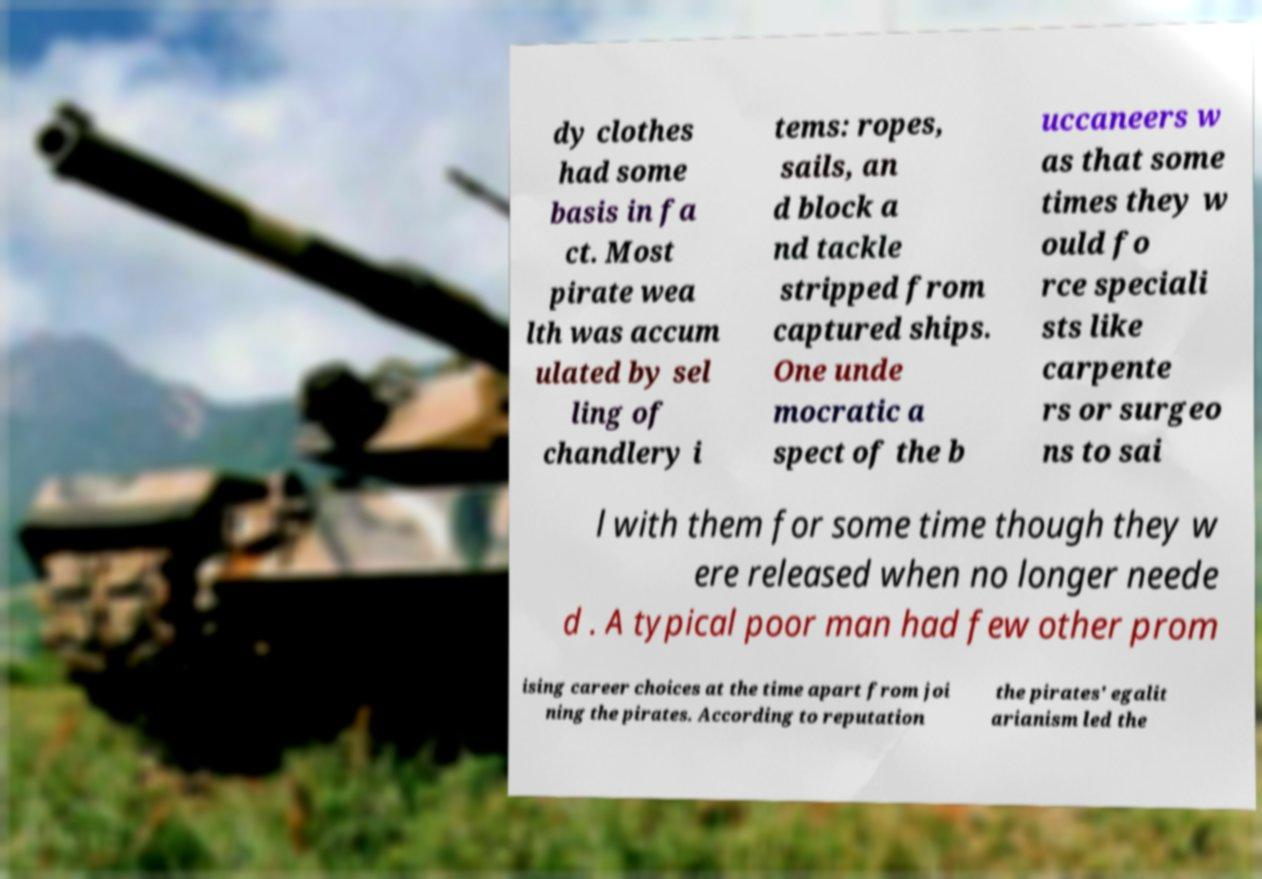Can you read and provide the text displayed in the image?This photo seems to have some interesting text. Can you extract and type it out for me? dy clothes had some basis in fa ct. Most pirate wea lth was accum ulated by sel ling of chandlery i tems: ropes, sails, an d block a nd tackle stripped from captured ships. One unde mocratic a spect of the b uccaneers w as that some times they w ould fo rce speciali sts like carpente rs or surgeo ns to sai l with them for some time though they w ere released when no longer neede d . A typical poor man had few other prom ising career choices at the time apart from joi ning the pirates. According to reputation the pirates' egalit arianism led the 